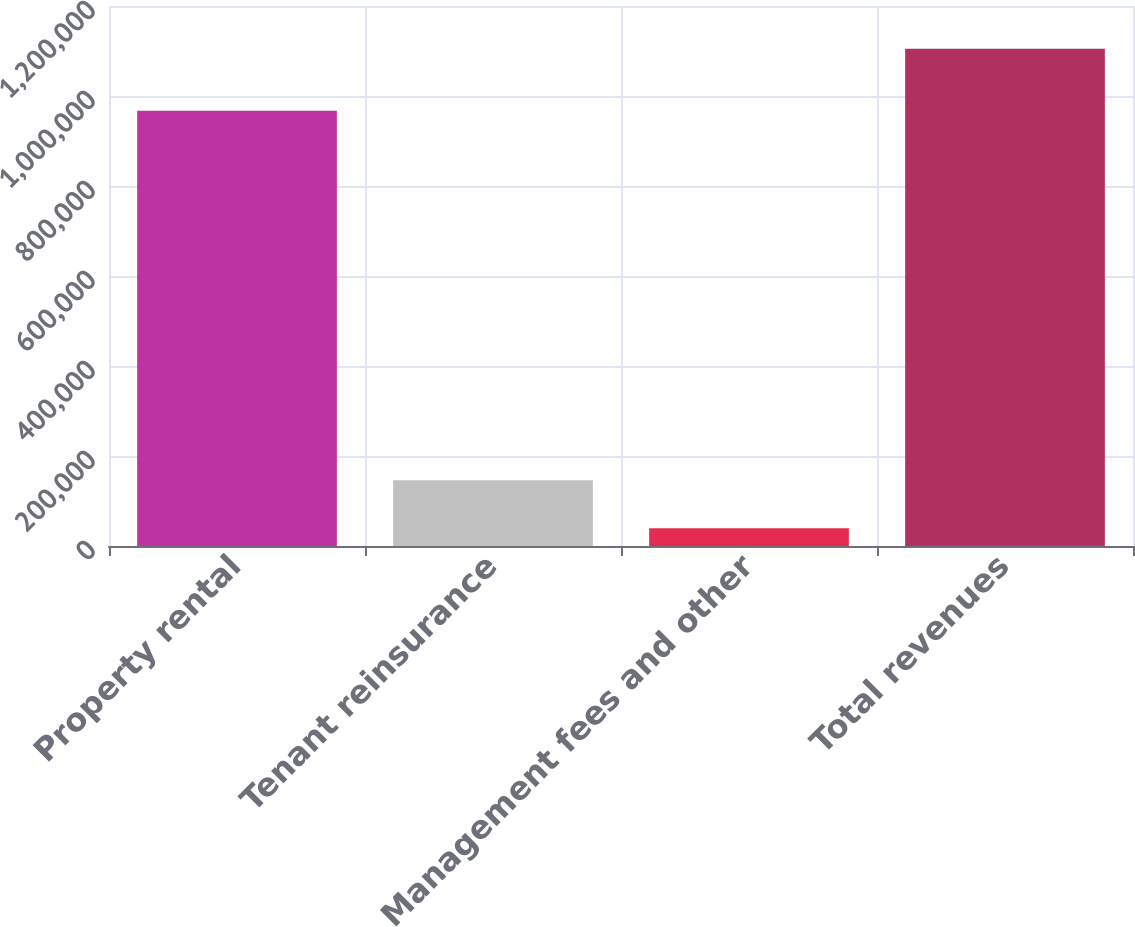Convert chart to OTSL. <chart><loc_0><loc_0><loc_500><loc_500><bar_chart><fcel>Property rental<fcel>Tenant reinsurance<fcel>Management fees and other<fcel>Total revenues<nl><fcel>967229<fcel>145942<fcel>39379<fcel>1.10501e+06<nl></chart> 